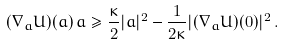<formula> <loc_0><loc_0><loc_500><loc_500>( \nabla _ { a } U ) ( a ) \, a \geq \frac { \kappa } { 2 } | a | ^ { 2 } - \frac { 1 } { 2 \kappa } | ( \nabla _ { a } U ) ( 0 ) | ^ { 2 } \, .</formula> 